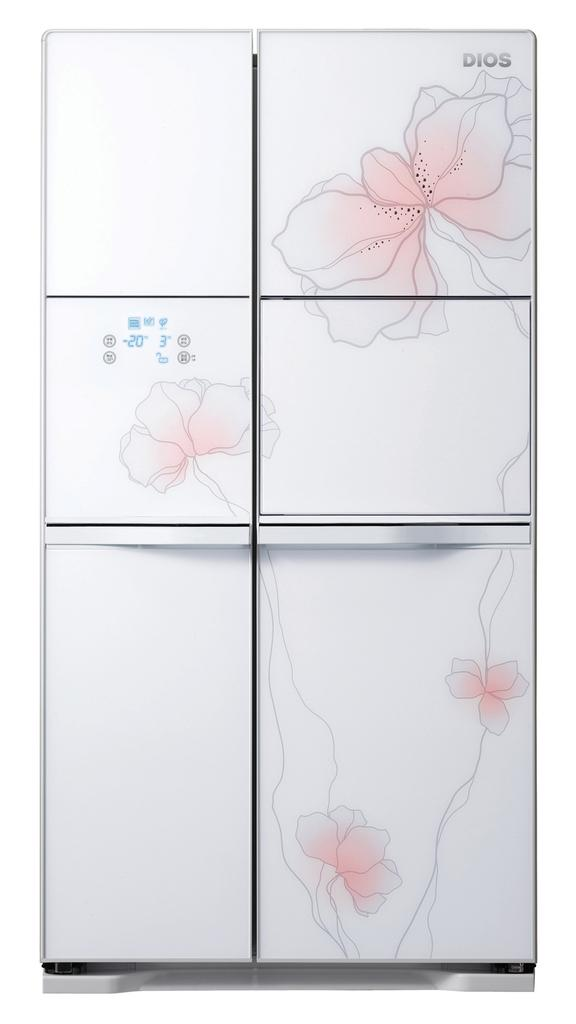What type of appliance is present in the image? There is a white color refrigerator in the image. What decorative elements are on the refrigerator? There are flowers on the refrigerator. What color is the background of the image? The background of the image is white. What story does the refrigerator tell about the friendship between the flowers and the sugar? There is no story, friendship, or sugar present in the image; it only features a white refrigerator with flowers on it. 